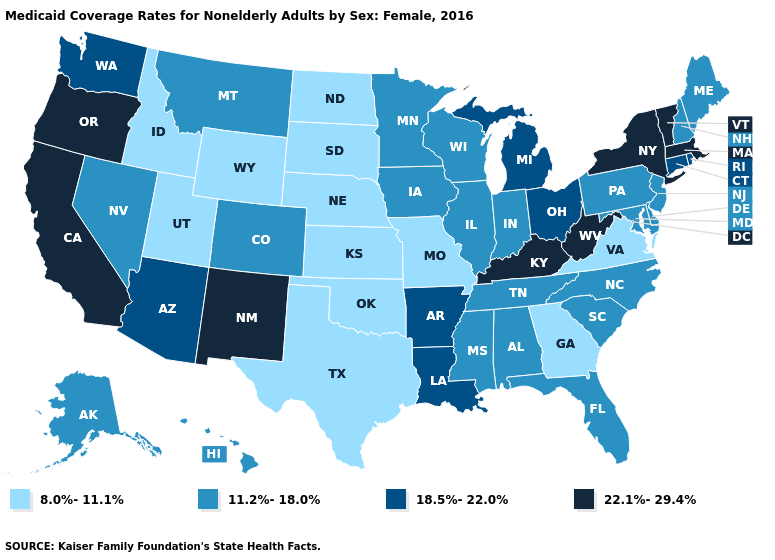Name the states that have a value in the range 22.1%-29.4%?
Give a very brief answer. California, Kentucky, Massachusetts, New Mexico, New York, Oregon, Vermont, West Virginia. What is the value of Illinois?
Keep it brief. 11.2%-18.0%. What is the lowest value in states that border Louisiana?
Be succinct. 8.0%-11.1%. Does the map have missing data?
Short answer required. No. What is the value of Connecticut?
Answer briefly. 18.5%-22.0%. What is the value of Nevada?
Give a very brief answer. 11.2%-18.0%. Among the states that border Arkansas , does Texas have the highest value?
Keep it brief. No. What is the highest value in the USA?
Answer briefly. 22.1%-29.4%. Name the states that have a value in the range 22.1%-29.4%?
Keep it brief. California, Kentucky, Massachusetts, New Mexico, New York, Oregon, Vermont, West Virginia. Is the legend a continuous bar?
Answer briefly. No. Name the states that have a value in the range 8.0%-11.1%?
Short answer required. Georgia, Idaho, Kansas, Missouri, Nebraska, North Dakota, Oklahoma, South Dakota, Texas, Utah, Virginia, Wyoming. Name the states that have a value in the range 8.0%-11.1%?
Quick response, please. Georgia, Idaho, Kansas, Missouri, Nebraska, North Dakota, Oklahoma, South Dakota, Texas, Utah, Virginia, Wyoming. How many symbols are there in the legend?
Keep it brief. 4. What is the value of Vermont?
Quick response, please. 22.1%-29.4%. Name the states that have a value in the range 18.5%-22.0%?
Answer briefly. Arizona, Arkansas, Connecticut, Louisiana, Michigan, Ohio, Rhode Island, Washington. 